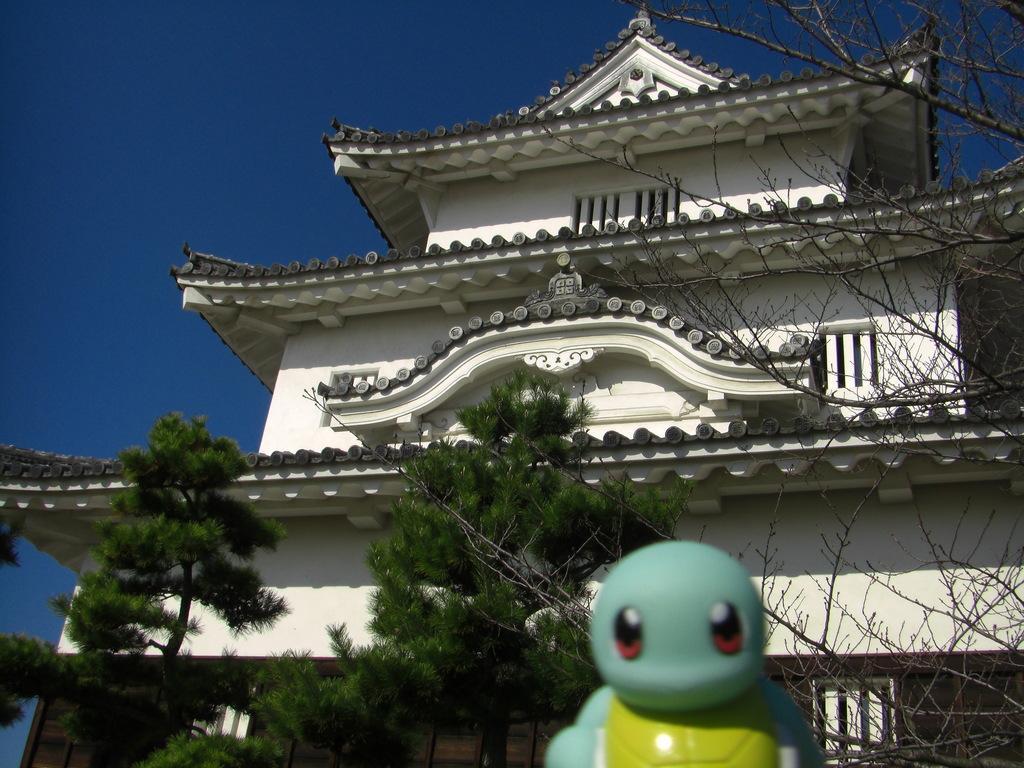Can you describe this image briefly? In this picture we can see a toy at the bottom, in the background there is a building and trees, we can see the sky at the top of the picture. 